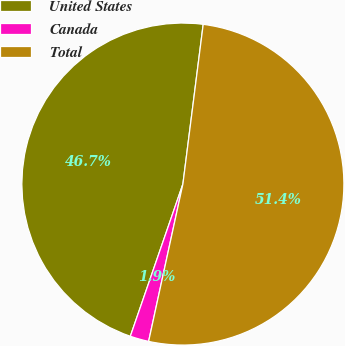Convert chart. <chart><loc_0><loc_0><loc_500><loc_500><pie_chart><fcel>United States<fcel>Canada<fcel>Total<nl><fcel>46.72%<fcel>1.88%<fcel>51.4%<nl></chart> 